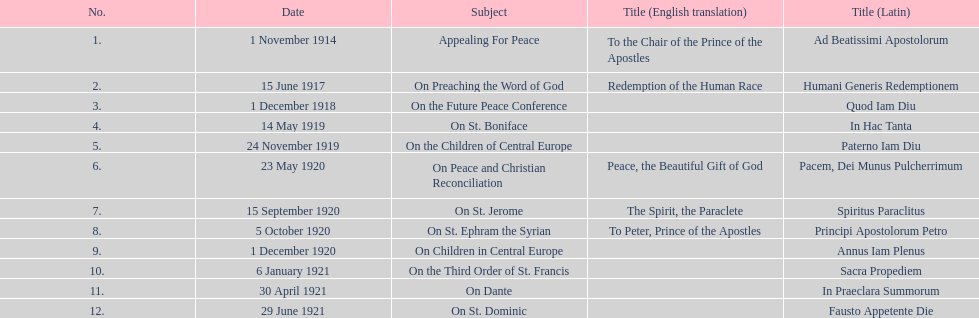What is the first english translation listed on the table? To the Chair of the Prince of the Apostles. 